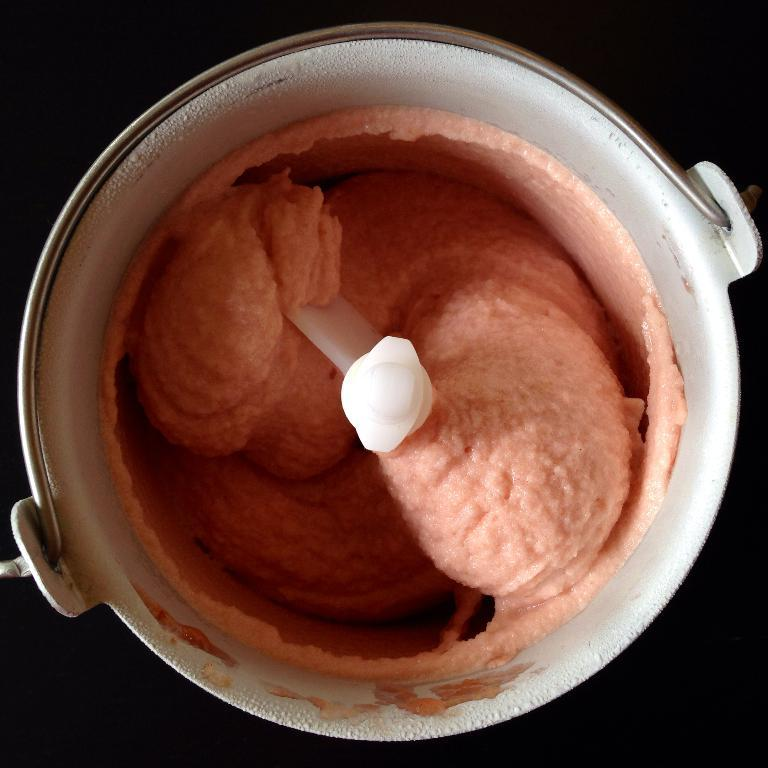What is the main object in the middle of the image? There is a jar in the middle of the image. What is inside the jar? Inside the jar, there is a mixer. What is the mixer used for? The mixer contains a food item. What is the color of the background in the image? The background of the image appears to be black. What type of love can be seen in the image? There is no love present in the image; it features a jar with a mixer containing a food item against a black background. 